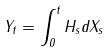Convert formula to latex. <formula><loc_0><loc_0><loc_500><loc_500>Y _ { t } = \int _ { 0 } ^ { t } H _ { s } d X _ { s }</formula> 